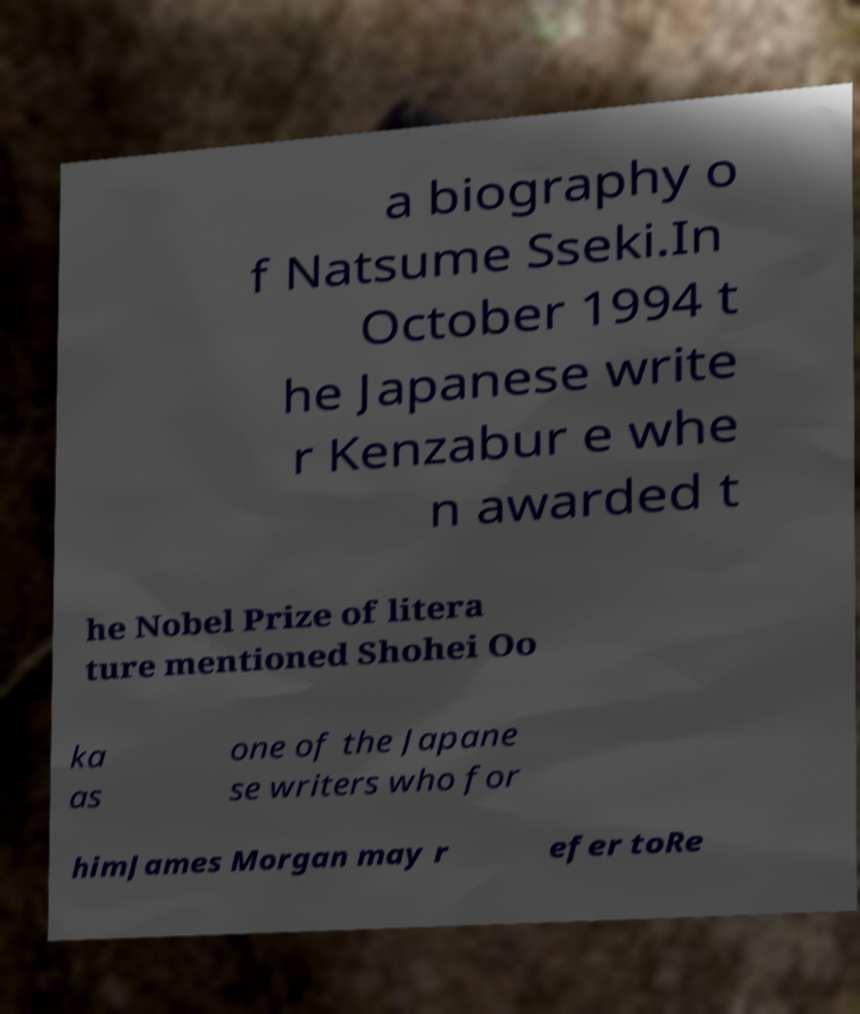Could you assist in decoding the text presented in this image and type it out clearly? a biography o f Natsume Sseki.In October 1994 t he Japanese write r Kenzabur e whe n awarded t he Nobel Prize of litera ture mentioned Shohei Oo ka as one of the Japane se writers who for himJames Morgan may r efer toRe 